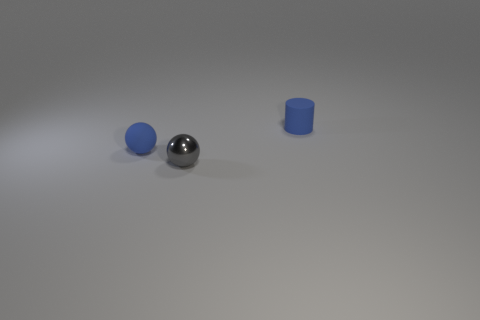How could these objects be used in a simple physics demonstration? These objects could be utilized to demonstrate various principles of physics. For example, the block can be used to illustrate stability and center of mass, as it will remain stationary due to its shape. The blue ball could show the concept of rolling and kinetic energy, as it can easily move across the surface. The cylinder can represent the ideas of balance and rotational motion. With a gentle push, it might roll, showcasing inertia and friction in action. 